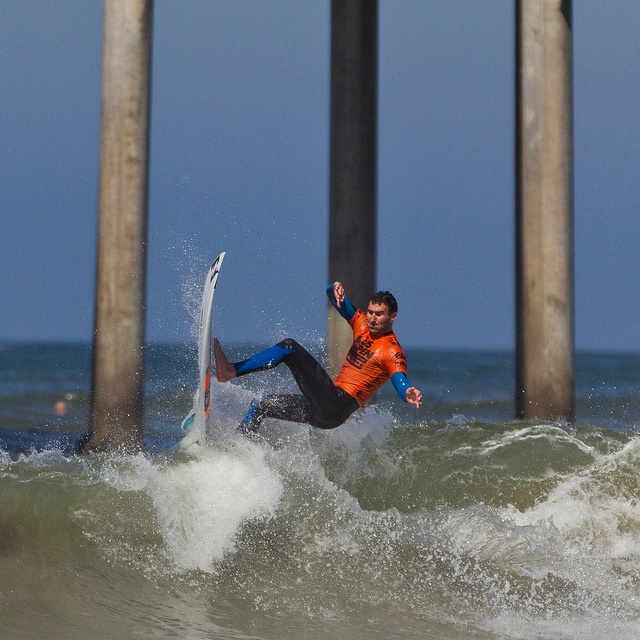Describe the objects in this image and their specific colors. I can see people in gray, black, maroon, red, and brown tones and surfboard in gray, darkgray, and lightgray tones in this image. 